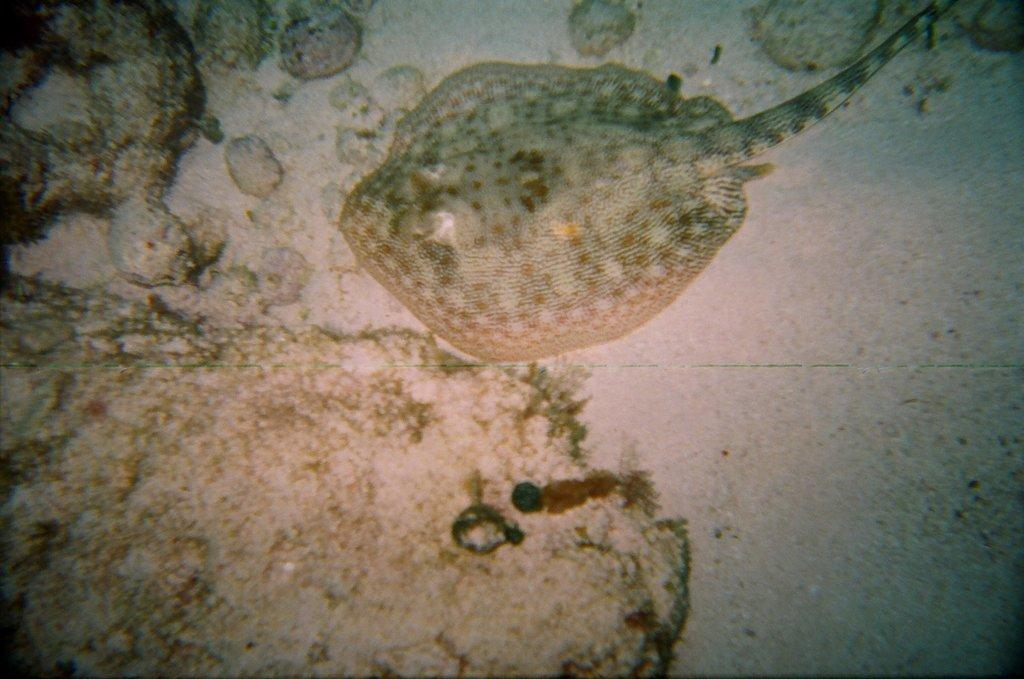What type of animal can be seen in the image? There is a sea animal in the image. What is the sea animal's location in relation to other objects in the image? The sea animal is near stones. What color is the background of the image? The background of the image is white. What is the sea animal's tendency to consume liquid in the image? There is no information about the sea animal's consumption of liquid in the image. 